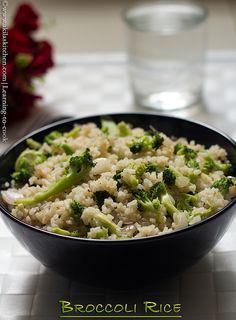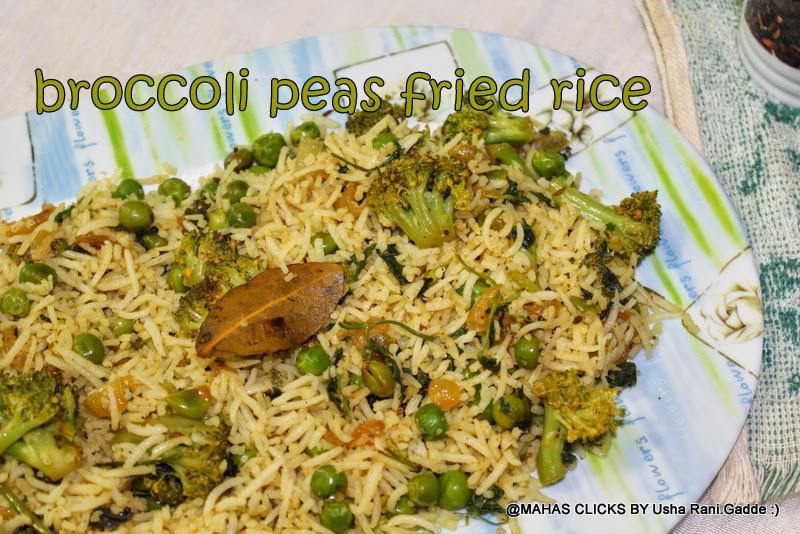The first image is the image on the left, the second image is the image on the right. Assess this claim about the two images: "There is at least one metal utensil in the image on the right.". Correct or not? Answer yes or no. No. 